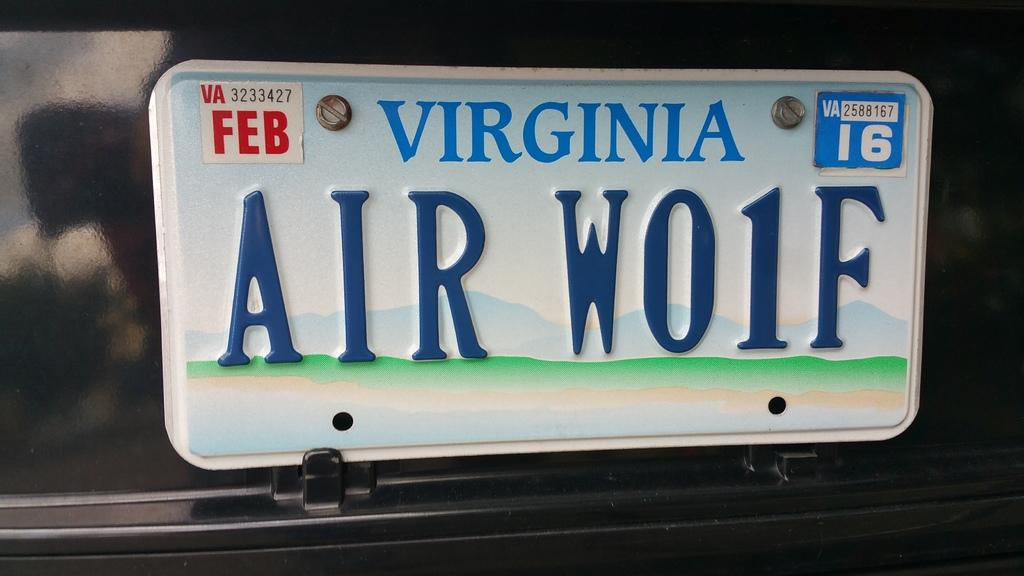<image>
Offer a succinct explanation of the picture presented. A Virginia licence plate with the words Air Wo1F 